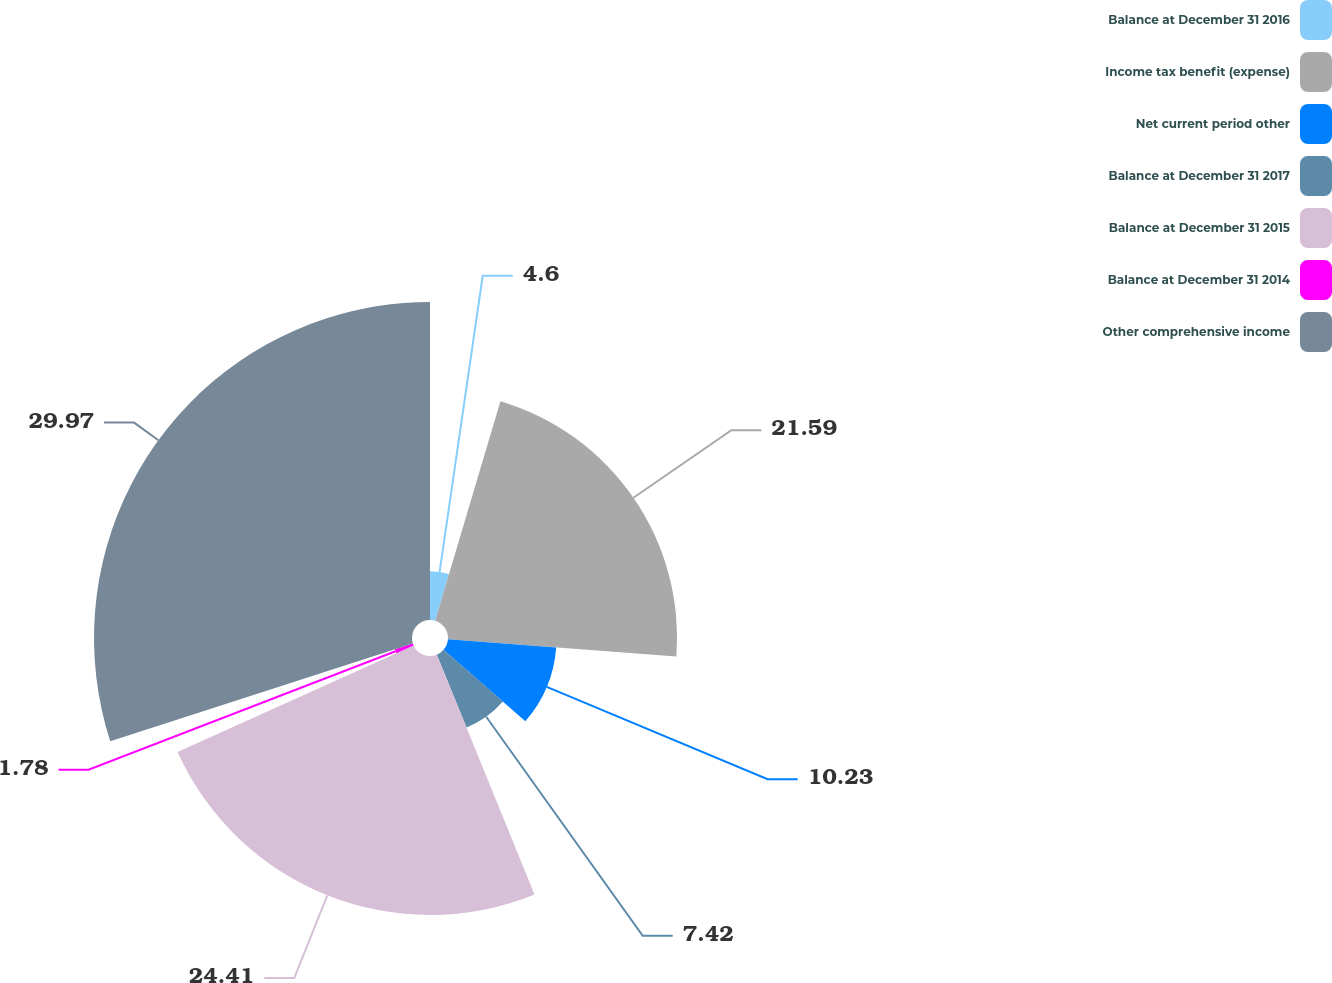Convert chart to OTSL. <chart><loc_0><loc_0><loc_500><loc_500><pie_chart><fcel>Balance at December 31 2016<fcel>Income tax benefit (expense)<fcel>Net current period other<fcel>Balance at December 31 2017<fcel>Balance at December 31 2015<fcel>Balance at December 31 2014<fcel>Other comprehensive income<nl><fcel>4.6%<fcel>21.59%<fcel>10.23%<fcel>7.42%<fcel>24.41%<fcel>1.78%<fcel>29.97%<nl></chart> 